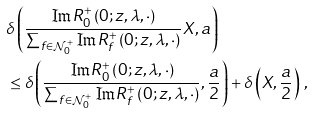<formula> <loc_0><loc_0><loc_500><loc_500>& \delta \left ( \frac { \Im R ^ { + } _ { 0 } \left ( 0 ; z , \lambda , \cdot \right ) } { \sum _ { f \in \mathcal { N } _ { 0 } ^ { + } } \Im R ^ { + } _ { f } \left ( 0 ; z , \lambda , \cdot \right ) } X , a \right ) \\ & \leq \delta \left ( \frac { \Im R ^ { + } _ { 0 } \left ( 0 ; z , \lambda , \cdot \right ) } { \sum _ { f \in \mathcal { N } _ { 0 } ^ { + } } \Im R ^ { + } _ { f } \left ( 0 ; z , \lambda , \cdot \right ) } , \frac { a } { 2 } \right ) + \delta \left ( X , \frac { a } { 2 } \right ) \, ,</formula> 